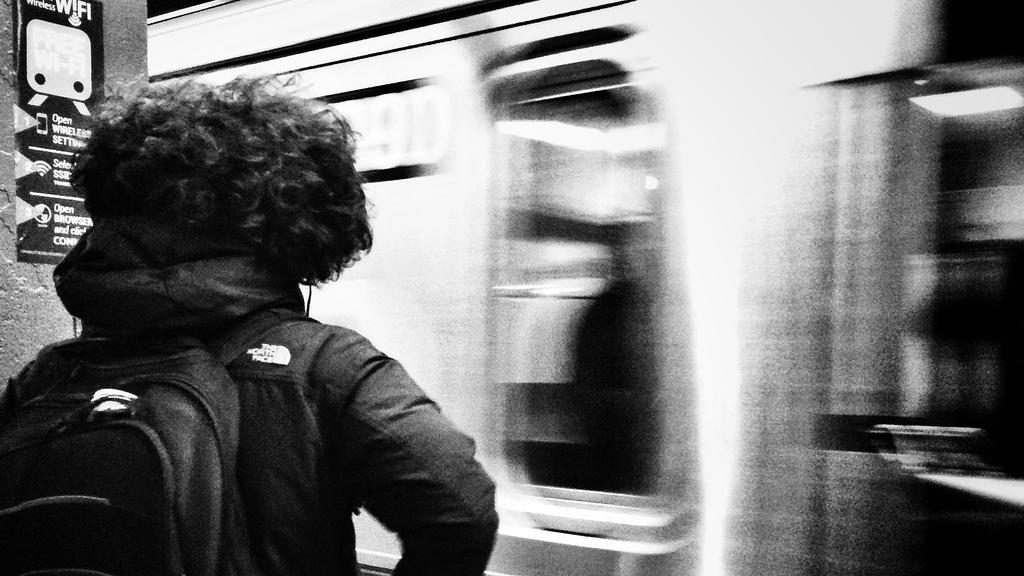What is located on the left side of the image? There is a man on the left side of the image. What is the man wearing? The man is wearing a coat. What is the man carrying? The man has a bag. What can be seen on the right side of the image? There appears to be a moving train on the right side of the image. What type of ice can be seen melting in the garden in the image? There is no ice or garden present in the image; it features a man wearing a coat and a moving train on the right side. 